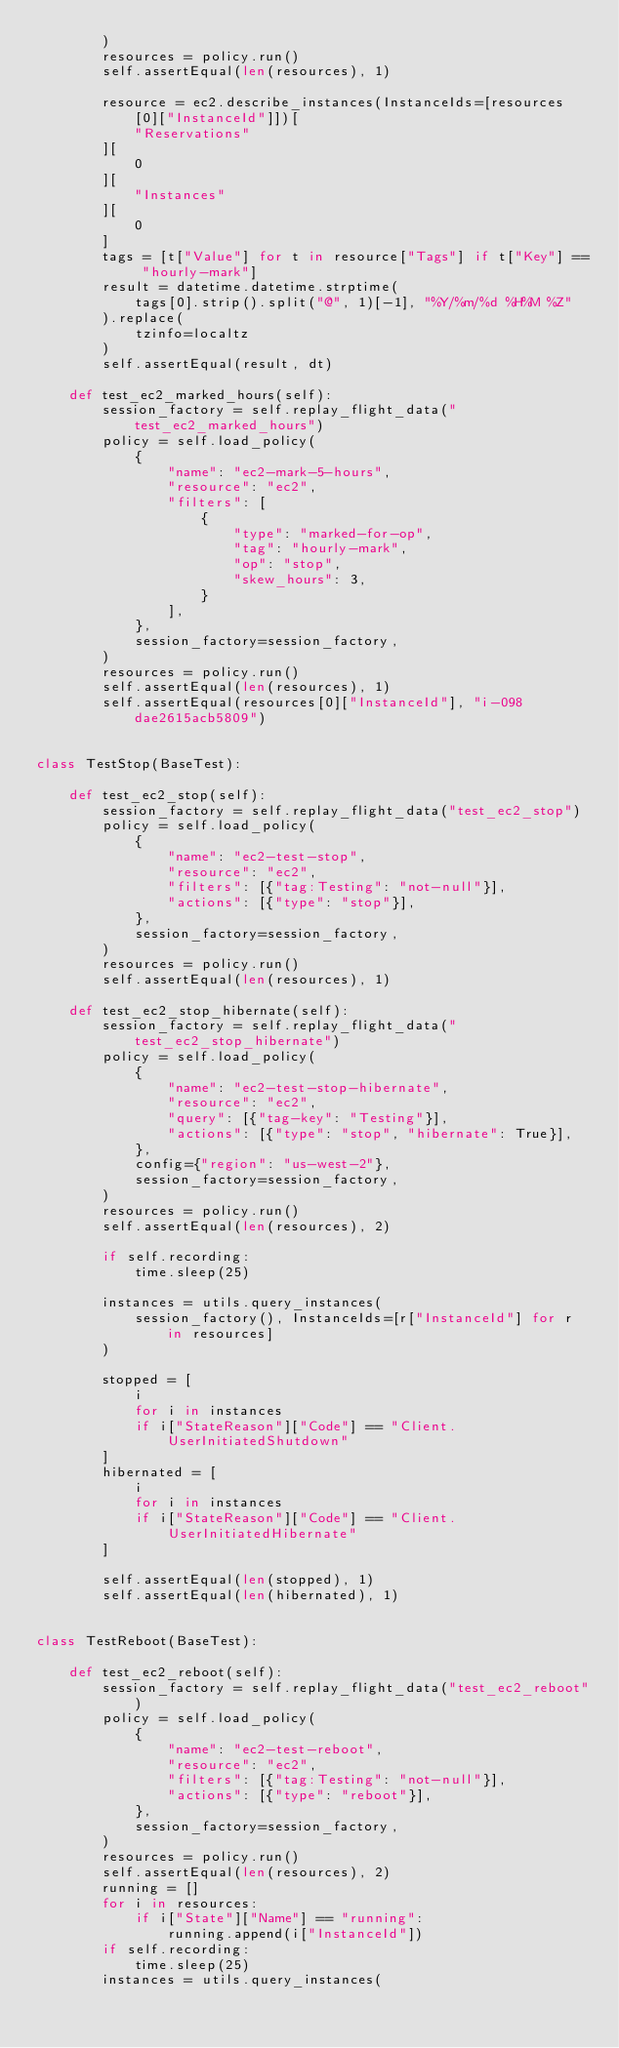<code> <loc_0><loc_0><loc_500><loc_500><_Python_>        )
        resources = policy.run()
        self.assertEqual(len(resources), 1)

        resource = ec2.describe_instances(InstanceIds=[resources[0]["InstanceId"]])[
            "Reservations"
        ][
            0
        ][
            "Instances"
        ][
            0
        ]
        tags = [t["Value"] for t in resource["Tags"] if t["Key"] == "hourly-mark"]
        result = datetime.datetime.strptime(
            tags[0].strip().split("@", 1)[-1], "%Y/%m/%d %H%M %Z"
        ).replace(
            tzinfo=localtz
        )
        self.assertEqual(result, dt)

    def test_ec2_marked_hours(self):
        session_factory = self.replay_flight_data("test_ec2_marked_hours")
        policy = self.load_policy(
            {
                "name": "ec2-mark-5-hours",
                "resource": "ec2",
                "filters": [
                    {
                        "type": "marked-for-op",
                        "tag": "hourly-mark",
                        "op": "stop",
                        "skew_hours": 3,
                    }
                ],
            },
            session_factory=session_factory,
        )
        resources = policy.run()
        self.assertEqual(len(resources), 1)
        self.assertEqual(resources[0]["InstanceId"], "i-098dae2615acb5809")


class TestStop(BaseTest):

    def test_ec2_stop(self):
        session_factory = self.replay_flight_data("test_ec2_stop")
        policy = self.load_policy(
            {
                "name": "ec2-test-stop",
                "resource": "ec2",
                "filters": [{"tag:Testing": "not-null"}],
                "actions": [{"type": "stop"}],
            },
            session_factory=session_factory,
        )
        resources = policy.run()
        self.assertEqual(len(resources), 1)

    def test_ec2_stop_hibernate(self):
        session_factory = self.replay_flight_data("test_ec2_stop_hibernate")
        policy = self.load_policy(
            {
                "name": "ec2-test-stop-hibernate",
                "resource": "ec2",
                "query": [{"tag-key": "Testing"}],
                "actions": [{"type": "stop", "hibernate": True}],
            },
            config={"region": "us-west-2"},
            session_factory=session_factory,
        )
        resources = policy.run()
        self.assertEqual(len(resources), 2)

        if self.recording:
            time.sleep(25)

        instances = utils.query_instances(
            session_factory(), InstanceIds=[r["InstanceId"] for r in resources]
        )

        stopped = [
            i
            for i in instances
            if i["StateReason"]["Code"] == "Client.UserInitiatedShutdown"
        ]
        hibernated = [
            i
            for i in instances
            if i["StateReason"]["Code"] == "Client.UserInitiatedHibernate"
        ]

        self.assertEqual(len(stopped), 1)
        self.assertEqual(len(hibernated), 1)


class TestReboot(BaseTest):

    def test_ec2_reboot(self):
        session_factory = self.replay_flight_data("test_ec2_reboot")
        policy = self.load_policy(
            {
                "name": "ec2-test-reboot",
                "resource": "ec2",
                "filters": [{"tag:Testing": "not-null"}],
                "actions": [{"type": "reboot"}],
            },
            session_factory=session_factory,
        )
        resources = policy.run()
        self.assertEqual(len(resources), 2)
        running = []
        for i in resources:
            if i["State"]["Name"] == "running":
                running.append(i["InstanceId"])
        if self.recording:
            time.sleep(25)
        instances = utils.query_instances(</code> 